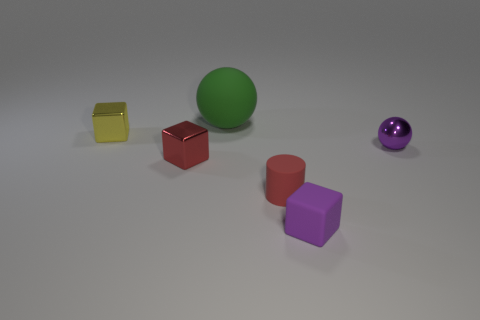Is there anything else that is made of the same material as the large thing?
Your response must be concise. Yes. Are there more large green matte spheres that are in front of the big rubber thing than green things?
Provide a short and direct response. No. There is a red shiny object that is to the right of the tiny object behind the tiny purple shiny thing; are there any rubber cylinders on the left side of it?
Ensure brevity in your answer.  No. There is a small red rubber cylinder; are there any green spheres to the right of it?
Your answer should be compact. No. How many objects have the same color as the tiny rubber cylinder?
Keep it short and to the point. 1. There is a cylinder that is the same material as the large green object; what size is it?
Offer a terse response. Small. What size is the purple thing left of the purple object behind the tiny red thing that is right of the green ball?
Provide a short and direct response. Small. What size is the shiny block to the left of the red metal object?
Offer a terse response. Small. How many purple objects are small spheres or tiny blocks?
Keep it short and to the point. 2. Is there another red cylinder that has the same size as the cylinder?
Offer a very short reply. No. 